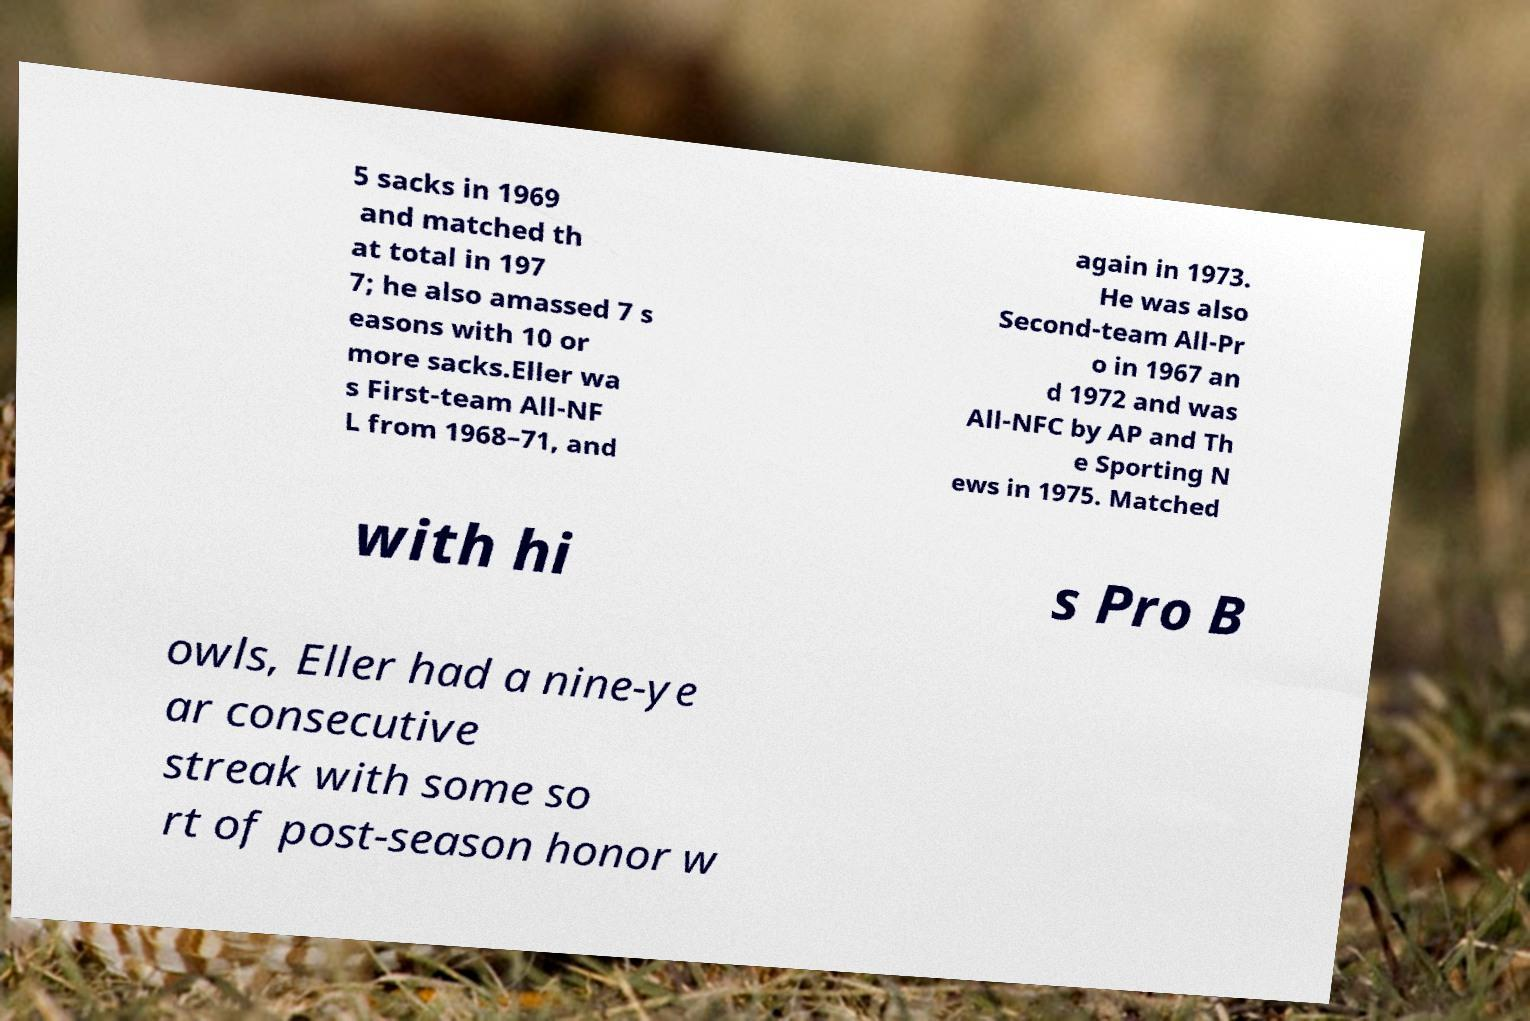I need the written content from this picture converted into text. Can you do that? 5 sacks in 1969 and matched th at total in 197 7; he also amassed 7 s easons with 10 or more sacks.Eller wa s First-team All-NF L from 1968–71, and again in 1973. He was also Second-team All-Pr o in 1967 an d 1972 and was All-NFC by AP and Th e Sporting N ews in 1975. Matched with hi s Pro B owls, Eller had a nine-ye ar consecutive streak with some so rt of post-season honor w 